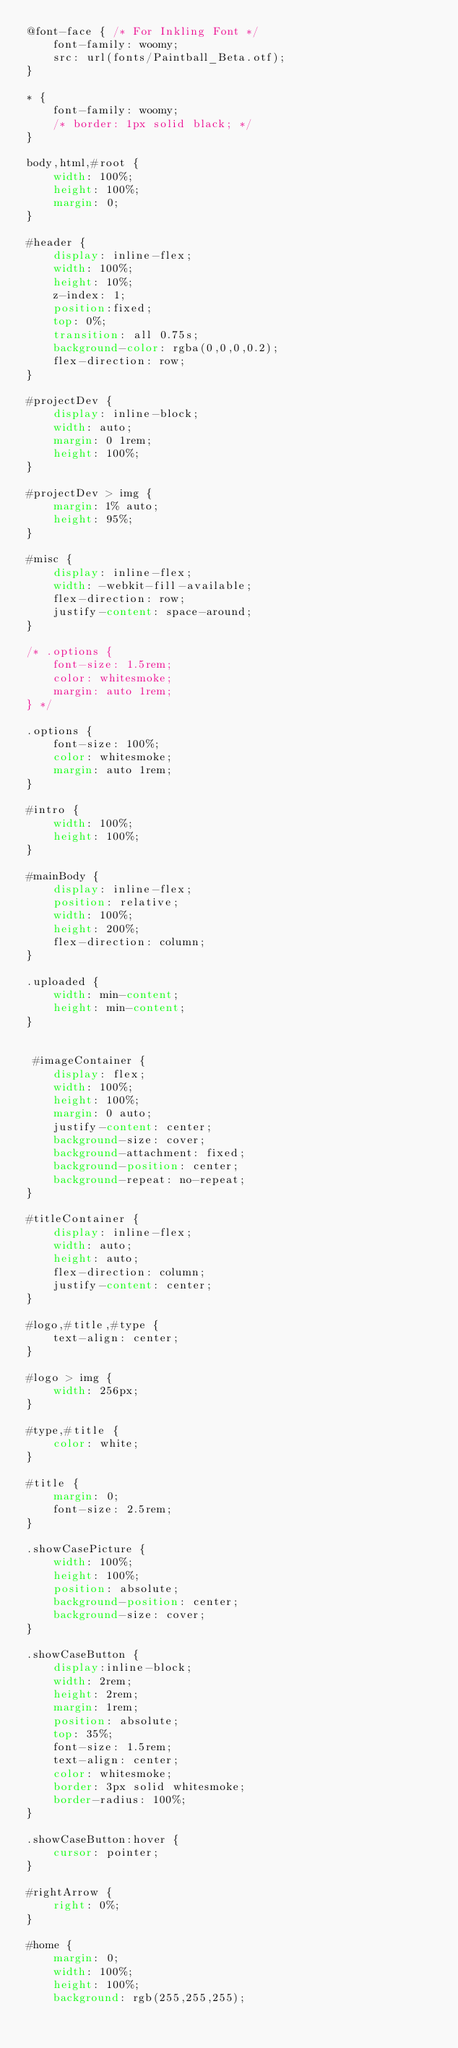Convert code to text. <code><loc_0><loc_0><loc_500><loc_500><_CSS_>@font-face { /* For Inkling Font */
    font-family: woomy;
    src: url(fonts/Paintball_Beta.otf);
}

* {
    font-family: woomy;
    /* border: 1px solid black; */
}

body,html,#root {
    width: 100%;
    height: 100%;
    margin: 0;
}

#header {
    display: inline-flex;
    width: 100%;
    height: 10%;
    z-index: 1;
    position:fixed;
    top: 0%;
    transition: all 0.75s;
    background-color: rgba(0,0,0,0.2);
    flex-direction: row;
} 

#projectDev {
    display: inline-block;
    width: auto;
    margin: 0 1rem;
    height: 100%;
}

#projectDev > img {
    margin: 1% auto;
    height: 95%;
}

#misc {
    display: inline-flex;
    width: -webkit-fill-available;
    flex-direction: row;
    justify-content: space-around;
}

/* .options {
    font-size: 1.5rem;
    color: whitesmoke;
    margin: auto 1rem;
} */

.options {
    font-size: 100%;
    color: whitesmoke;
    margin: auto 1rem;
}

#intro {
    width: 100%;
    height: 100%;
}

#mainBody {
    display: inline-flex;
    position: relative;
    width: 100%;
    height: 200%;
    flex-direction: column;
}

.uploaded {
    width: min-content;
    height: min-content;
}


 #imageContainer {
    display: flex;
    width: 100%;
    height: 100%;
    margin: 0 auto;
    justify-content: center;
    background-size: cover;
    background-attachment: fixed;
    background-position: center;
    background-repeat: no-repeat;
}

#titleContainer {
    display: inline-flex;
    width: auto;
    height: auto;
    flex-direction: column;
    justify-content: center;
}

#logo,#title,#type {
    text-align: center;
}

#logo > img {
    width: 256px;
}

#type,#title {
    color: white;
}

#title {
    margin: 0;
    font-size: 2.5rem;
}

.showCasePicture {
    width: 100%;
    height: 100%;
    position: absolute;
    background-position: center;
    background-size: cover;
}

.showCaseButton {
    display:inline-block;
    width: 2rem;
    height: 2rem;
    margin: 1rem;
    position: absolute;
    top: 35%;
    font-size: 1.5rem;
    text-align: center;
    color: whitesmoke;
    border: 3px solid whitesmoke;
    border-radius: 100%;
}

.showCaseButton:hover {
    cursor: pointer;
}

#rightArrow {
    right: 0%;
}

#home {
    margin: 0;
    width: 100%;
    height: 100%;
    background: rgb(255,255,255);</code> 